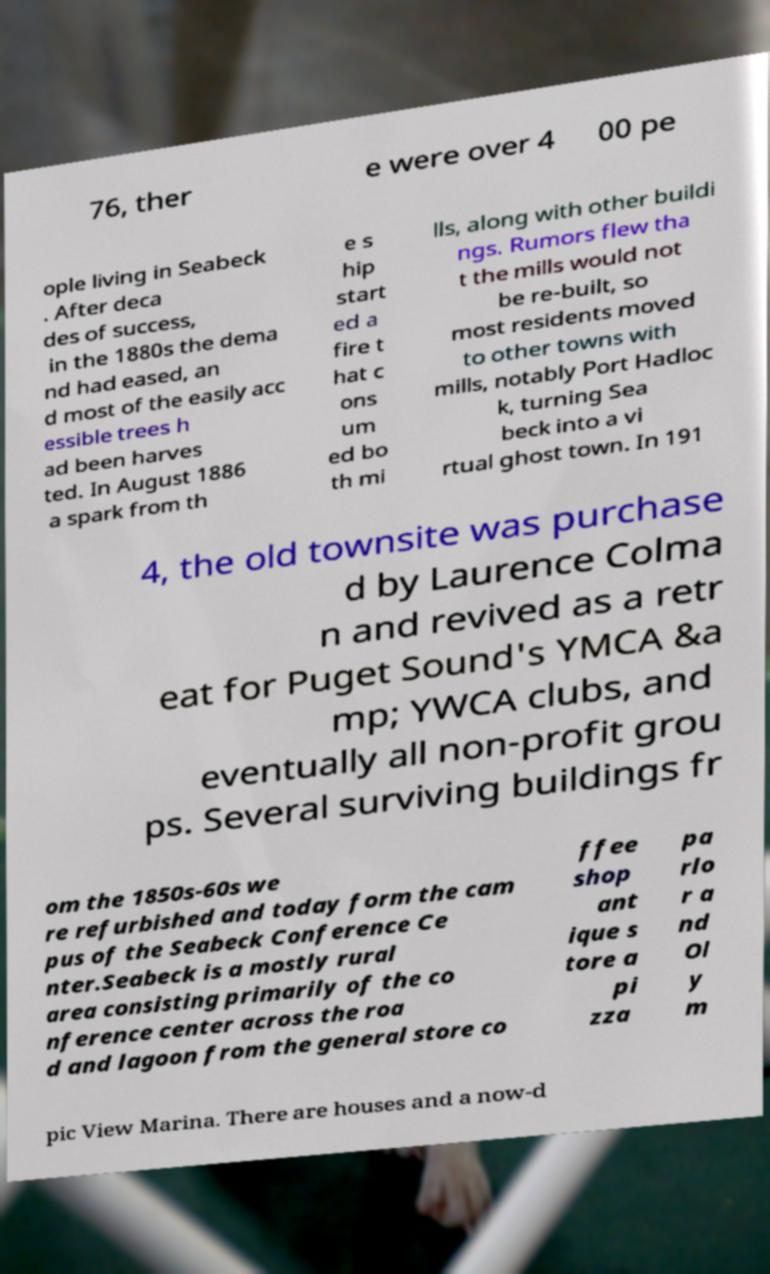Can you accurately transcribe the text from the provided image for me? 76, ther e were over 4 00 pe ople living in Seabeck . After deca des of success, in the 1880s the dema nd had eased, an d most of the easily acc essible trees h ad been harves ted. In August 1886 a spark from th e s hip start ed a fire t hat c ons um ed bo th mi lls, along with other buildi ngs. Rumors flew tha t the mills would not be re-built, so most residents moved to other towns with mills, notably Port Hadloc k, turning Sea beck into a vi rtual ghost town. In 191 4, the old townsite was purchase d by Laurence Colma n and revived as a retr eat for Puget Sound's YMCA &a mp; YWCA clubs, and eventually all non-profit grou ps. Several surviving buildings fr om the 1850s-60s we re refurbished and today form the cam pus of the Seabeck Conference Ce nter.Seabeck is a mostly rural area consisting primarily of the co nference center across the roa d and lagoon from the general store co ffee shop ant ique s tore a pi zza pa rlo r a nd Ol y m pic View Marina. There are houses and a now-d 